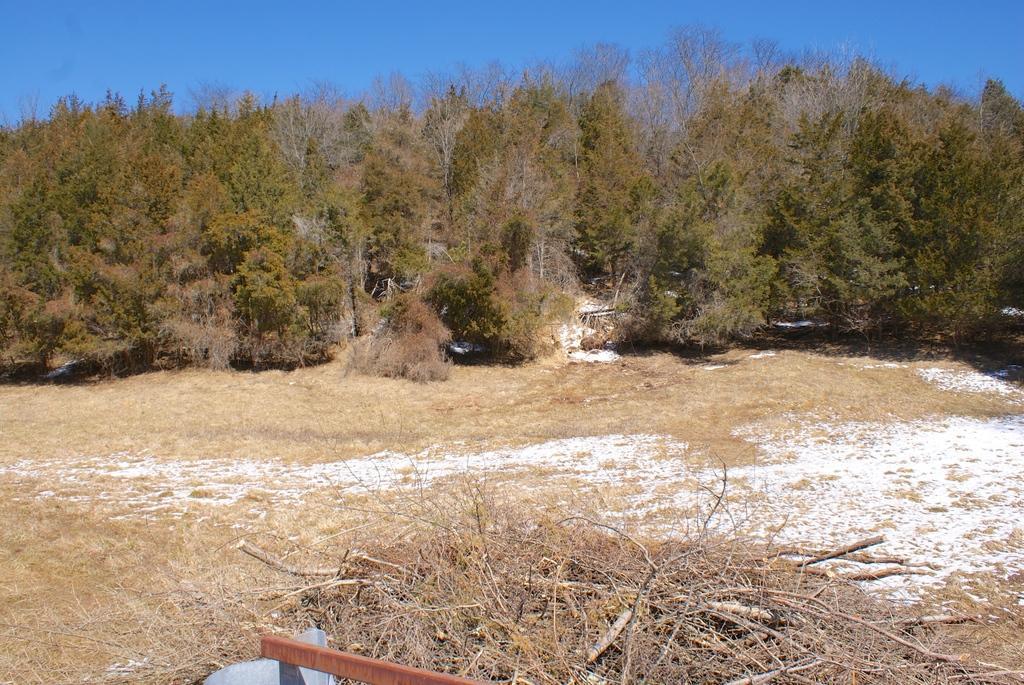How would you summarize this image in a sentence or two? In the foreground of the picture there are dry grass, twigs, an iron object and soil. In the center of the picture there are trees and shrubs. Sky is sunny. 